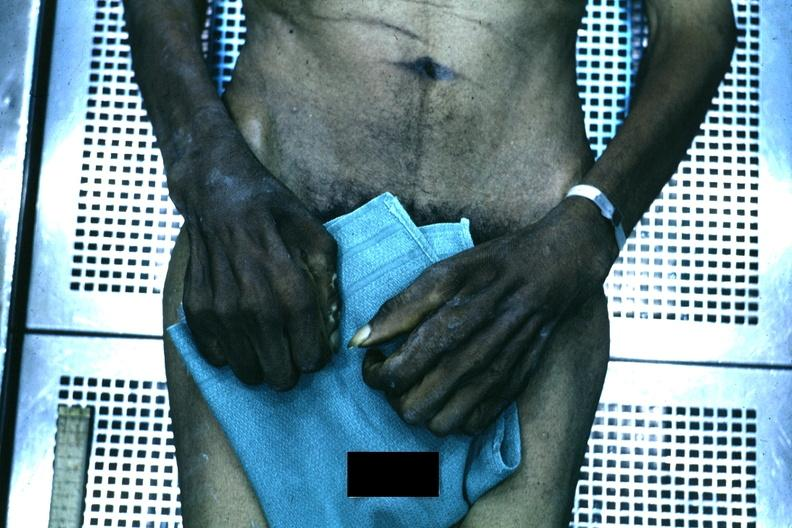what said to be due to syringomyelia?
Answer the question using a single word or phrase. Good example of muscle atrophy 